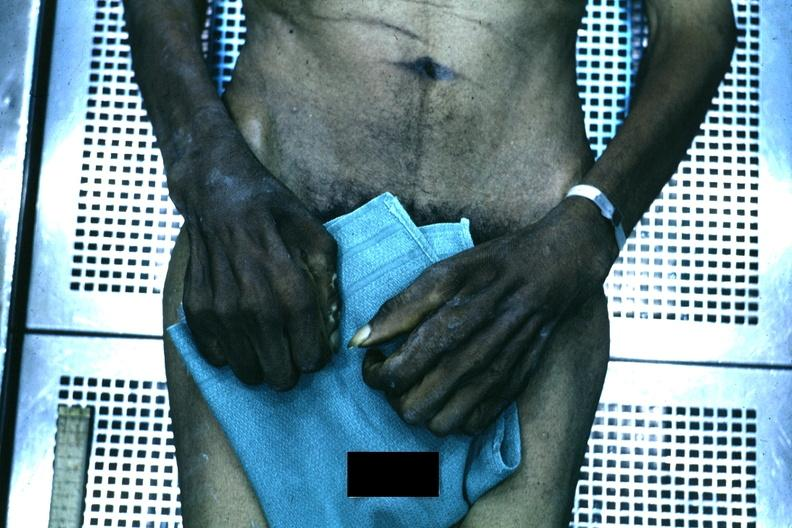what said to be due to syringomyelia?
Answer the question using a single word or phrase. Good example of muscle atrophy 